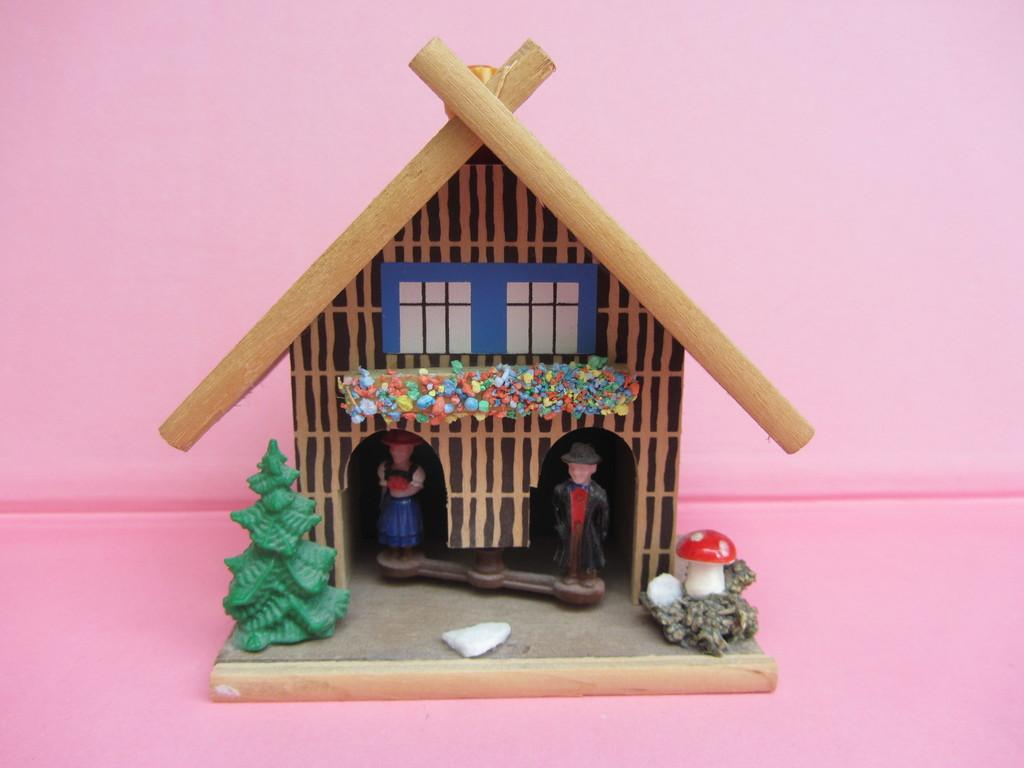What is the main object in the image? There is a toy house in the image. What is the toy house placed on? The toy house is on a pink surface. What color is the background of the image? The background of the image is pink. How does the fog affect the visibility of the toy house in the image? There is no fog present in the image, so it does not affect the visibility of the toy house. 